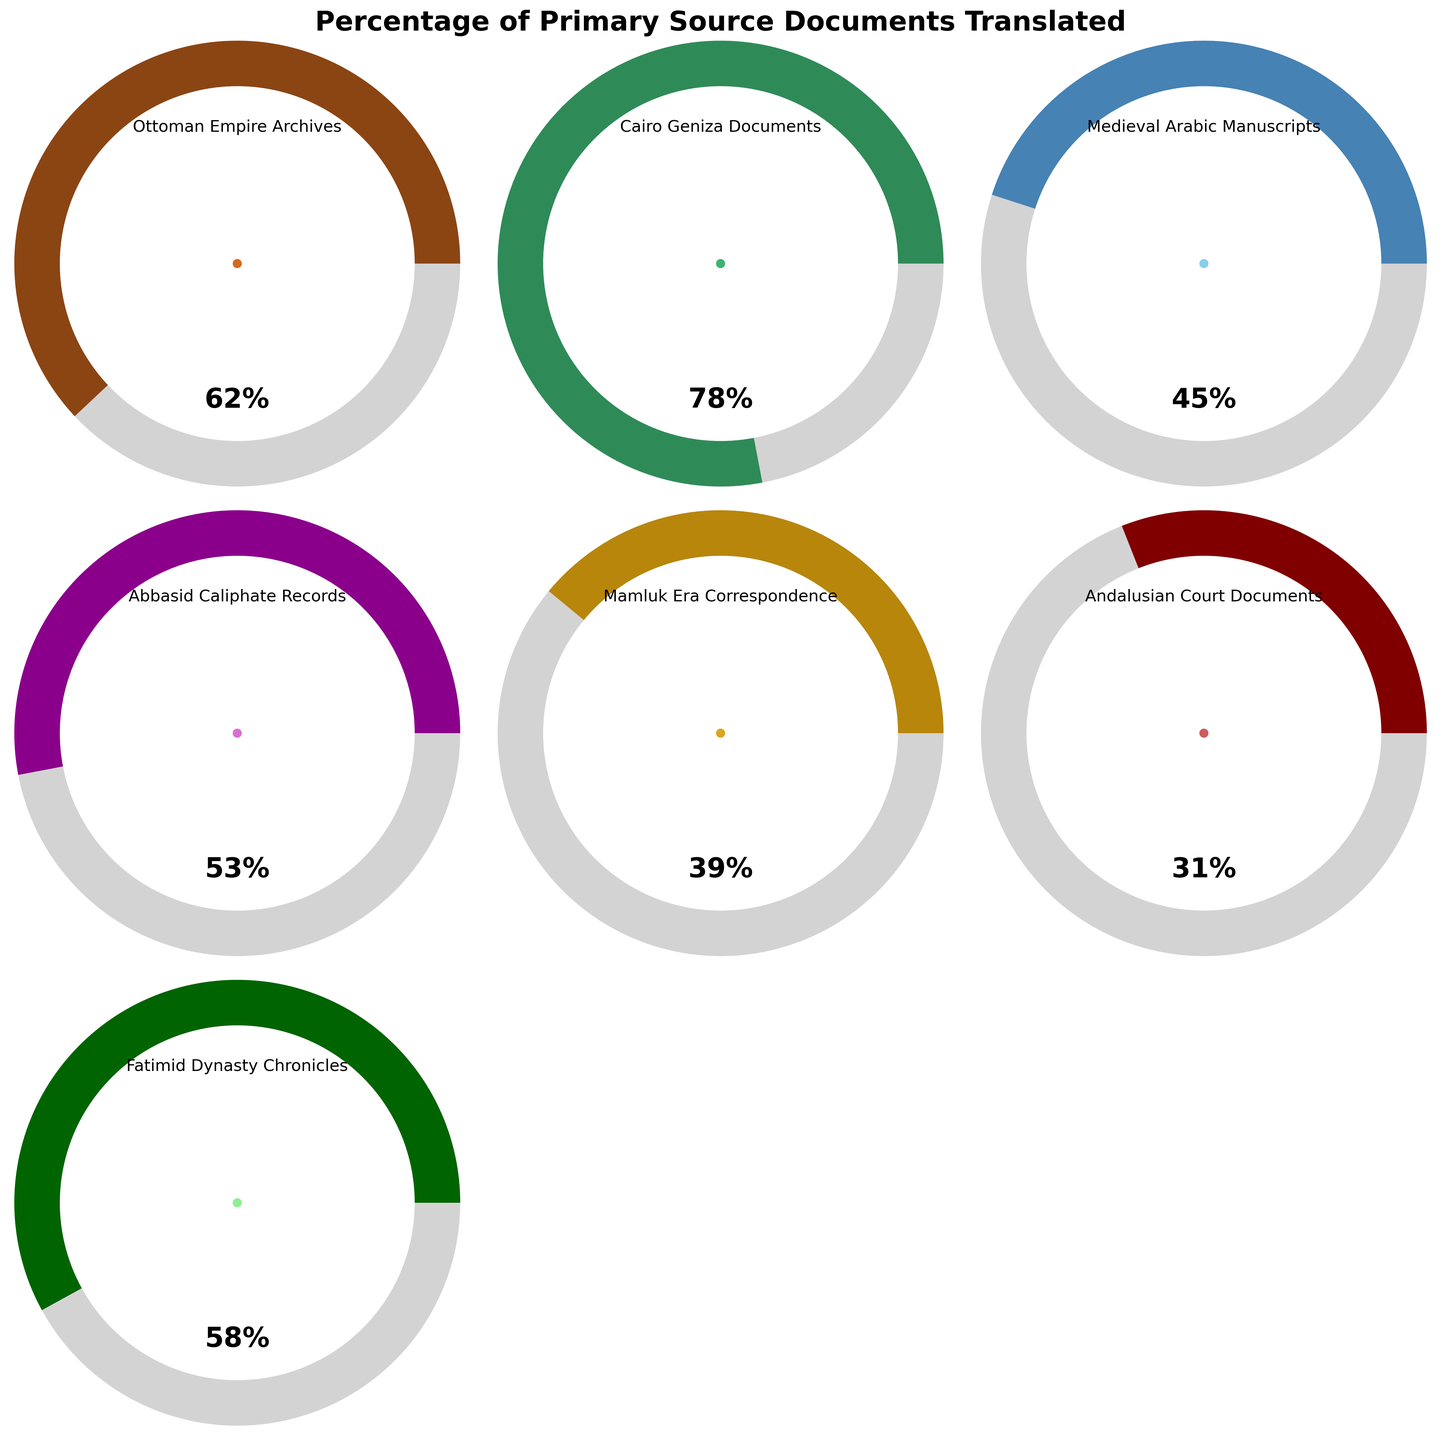What is the title of the figure? The title is usually at the top of the figure, describing what the figure represents. In this case, it is "Percentage of Primary Source Documents Translated" as mentioned in the code.
Answer: Percentage of Primary Source Documents Translated What is the percentage of translated documents for the Cairo Geniza Documents? Locate the gauge corresponding to "Cairo Geniza Documents." The percentage is displayed within the gauge. Here it is shown as 78%.
Answer: 78% Which primary source has the lowest percentage of documents translated? Compare all gauges to find the one with the smallest percentage. The Andalusian Court Documents have the lowest translation percentage at 31%.
Answer: Andalusian Court Documents How many primary sources are represented in the plot? Count the number of gauges, or alternatively, count the number of entries in the data provided. There are 7 entries.
Answer: 7 Which primary source has a higher percentage of translated documents: Fatimid Dynasty Chronicles or Abbasid Caliphate Records? Compare the percentages of the Fatimid Dynasty Chronicles (58%) and Abbasid Caliphate Records (53%). The Fatimid Dynasty Chronicles have a higher percentage.
Answer: Fatimid Dynasty Chronicles What is the average percentage of translated documents across all primary sources? Add all the given percentages and divide by the number of primary sources: (62+78+45+53+39+31+58)/7 = 52.29.
Answer: 52.29 Which two primary sources have the most similar percentages of translated documents? Look for the pair with the closest values. Comparing all, Ottoman Empire Archives (62%) and Fatimid Dynasty Chronicles (58%) are the closest.
Answer: Ottoman Empire Archives and Fatimid Dynasty Chronicles How much greater is the percentage of translated documents for Medieval Arabic Manuscripts compared to Mamluk Era Correspondence? Subtract Mamluk Era Correspondence (39%) from Medieval Arabic Manuscripts (45%): 45% - 39% = 6%.
Answer: 6% What is the range of the percentages of translated documents? Subtract the smallest percentage (Andalusian Court Documents, 31%) from the largest (Cairo Geniza Documents, 78%): 78% - 31% = 47%.
Answer: 47% Which primary sources have translation percentages above 50%? Identify which sources have a percentage greater than 50%. Ottoman Empire Archives (62%), Cairo Geniza Documents (78%), Abbasid Caliphate Records (53%), and Fatimid Dynasty Chronicles (58%) are above 50%.
Answer: Ottoman Empire Archives, Cairo Geniza Documents, Abbasid Caliphate Records, Fatimid Dynasty Chronicles 